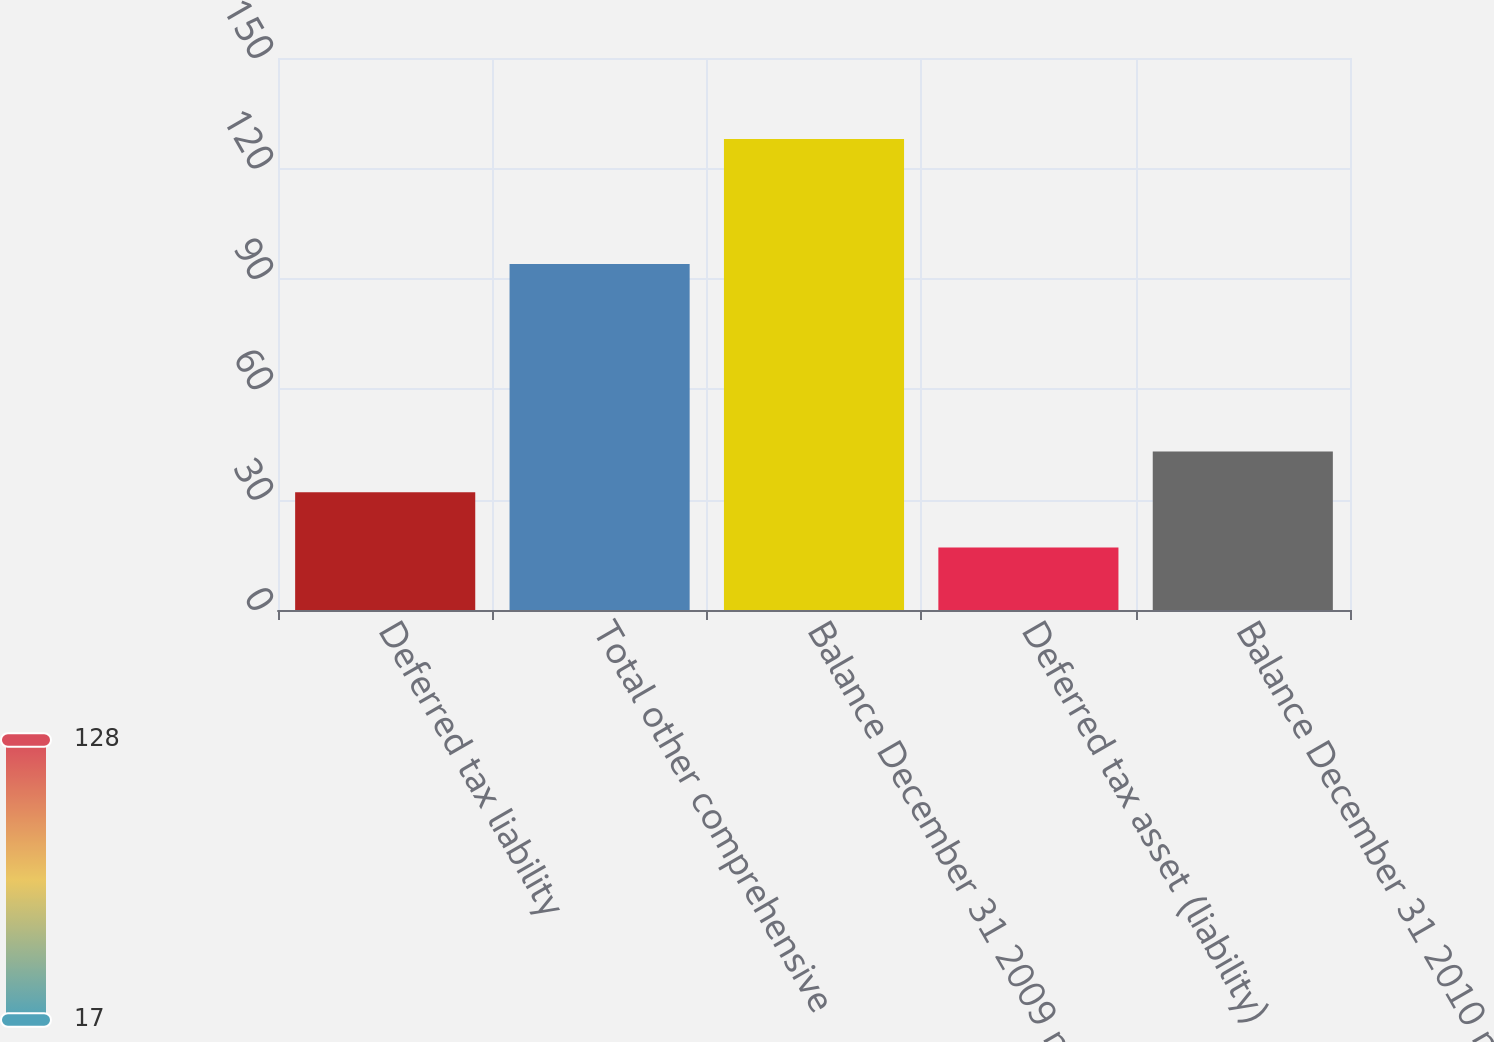Convert chart. <chart><loc_0><loc_0><loc_500><loc_500><bar_chart><fcel>Deferred tax liability<fcel>Total other comprehensive<fcel>Balance December 31 2009 net<fcel>Deferred tax asset (liability)<fcel>Balance December 31 2010 net<nl><fcel>32<fcel>94<fcel>128<fcel>17<fcel>43.1<nl></chart> 